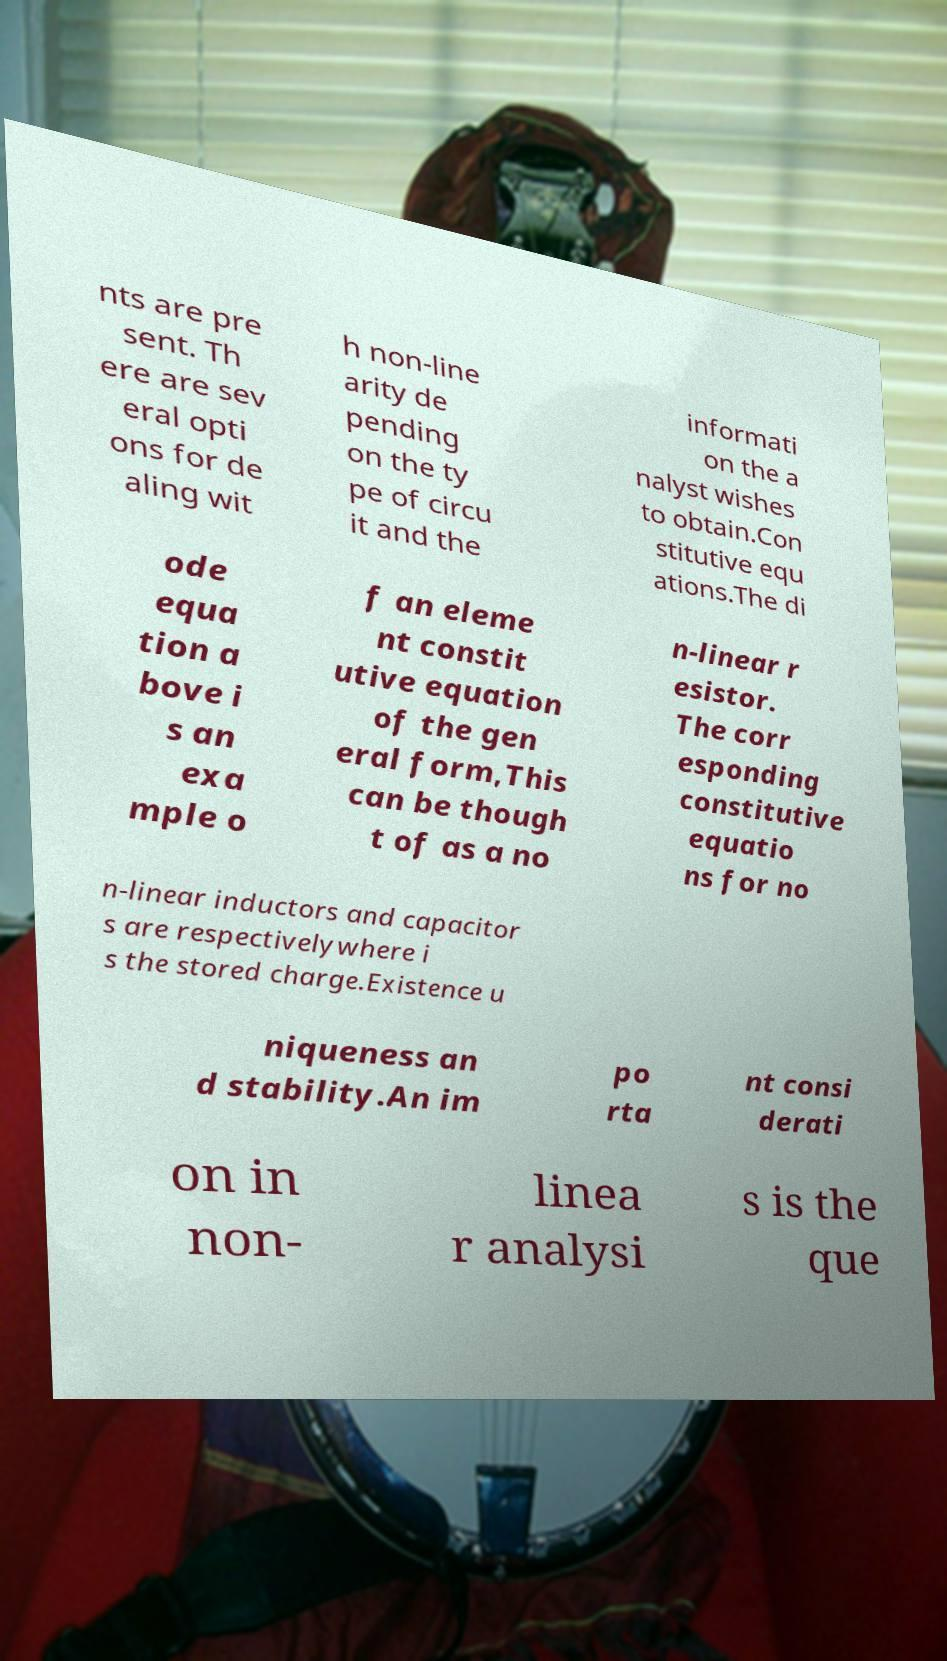Please identify and transcribe the text found in this image. nts are pre sent. Th ere are sev eral opti ons for de aling wit h non-line arity de pending on the ty pe of circu it and the informati on the a nalyst wishes to obtain.Con stitutive equ ations.The di ode equa tion a bove i s an exa mple o f an eleme nt constit utive equation of the gen eral form,This can be though t of as a no n-linear r esistor. The corr esponding constitutive equatio ns for no n-linear inductors and capacitor s are respectivelywhere i s the stored charge.Existence u niqueness an d stability.An im po rta nt consi derati on in non- linea r analysi s is the que 